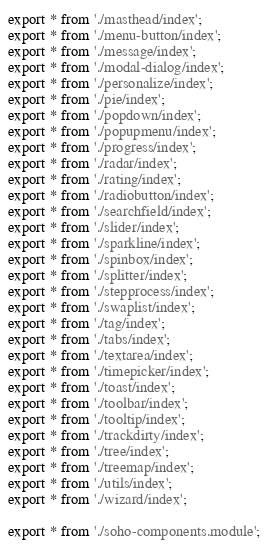Convert code to text. <code><loc_0><loc_0><loc_500><loc_500><_TypeScript_>export * from './masthead/index';
export * from './menu-button/index';
export * from './message/index';
export * from './modal-dialog/index';
export * from './personalize/index';
export * from './pie/index';
export * from './popdown/index';
export * from './popupmenu/index';
export * from './progress/index';
export * from './radar/index';
export * from './rating/index';
export * from './radiobutton/index';
export * from './searchfield/index';
export * from './slider/index';
export * from './sparkline/index';
export * from './spinbox/index';
export * from './splitter/index';
export * from './stepprocess/index';
export * from './swaplist/index';
export * from './tag/index';
export * from './tabs/index';
export * from './textarea/index';
export * from './timepicker/index';
export * from './toast/index';
export * from './toolbar/index';
export * from './tooltip/index';
export * from './trackdirty/index';
export * from './tree/index';
export * from './treemap/index';
export * from './utils/index';
export * from './wizard/index';

export * from './soho-components.module';
</code> 